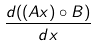Convert formula to latex. <formula><loc_0><loc_0><loc_500><loc_500>\frac { d ( ( A x ) \circ B ) } { d x }</formula> 